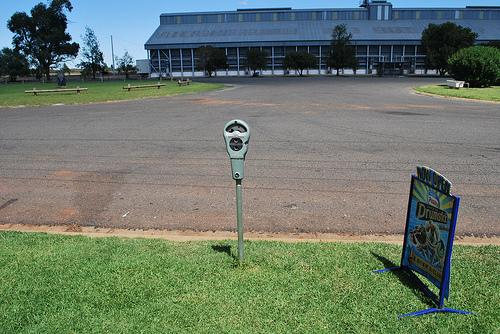List three objects found in the scene and provide a brief description of their location. A parking meter in the grass near a paved roadway, a colorful ice cream sign on the grass with a blue frame, and a large empty parking lot behind log railings and benches. Provide a detailed explanation of the object interactions in this scene. In the scene, bushes and trees grow against the front of a building, log railings, and benches creating a barrier, and a parking meter is located near the road and grassy area, likely indicating a parking spot close by. What is the dominant color of the grass, and is it long or short? The grass is green and short in color. Count and describe the types of seating objects found in the image. There are three small wooden benches placed in the grassy area. Evaluate the quality of the image and if there is any noise or distortion. The quality of the image appears to be clear and without any significant noise or distortion. Express the overall atmosphere and feeling of the image. The image has a calm, peaceful, and welcoming atmosphere with open spaces to sit and enjoy the surroundings. Provide an estimation of the total number of objects in the image. There are approximately 30 objects in the image, including benches, parking meters, signs, and trees. Analyze the image and infer whether it was taken during a daytime or nighttime setting. The image appears to be taken during daytime, as the sky seems bright and objects cast shadows on the ground. Based on the presence of certain objects, describe the possible purpose of this location. The location is likely a recreational area or park, as there are wooden benches, grassy areas, log railings, and nearby buildings. Examine the image and describe any notable visual features that stand out. A colorful sign in a blue frame advertising ice cream stands out, as well as the large tree by the building, benches, and parking meter located near the curb along the road. 